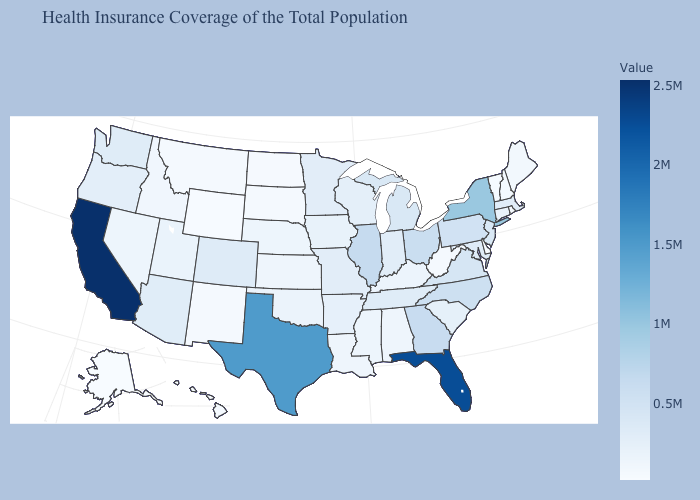Does Montana have the lowest value in the USA?
Concise answer only. No. Does West Virginia have the lowest value in the USA?
Answer briefly. No. Does the map have missing data?
Quick response, please. No. 